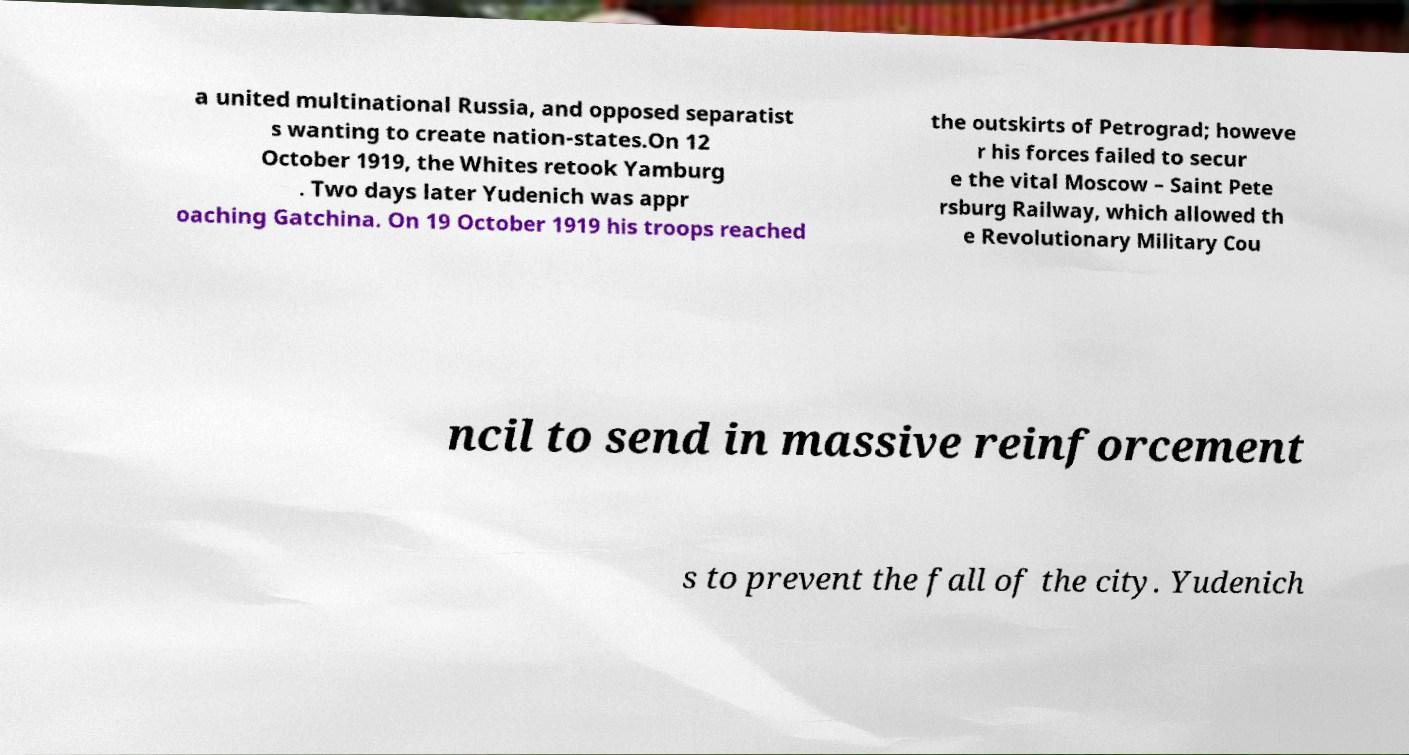Can you read and provide the text displayed in the image?This photo seems to have some interesting text. Can you extract and type it out for me? a united multinational Russia, and opposed separatist s wanting to create nation-states.On 12 October 1919, the Whites retook Yamburg . Two days later Yudenich was appr oaching Gatchina. On 19 October 1919 his troops reached the outskirts of Petrograd; howeve r his forces failed to secur e the vital Moscow – Saint Pete rsburg Railway, which allowed th e Revolutionary Military Cou ncil to send in massive reinforcement s to prevent the fall of the city. Yudenich 